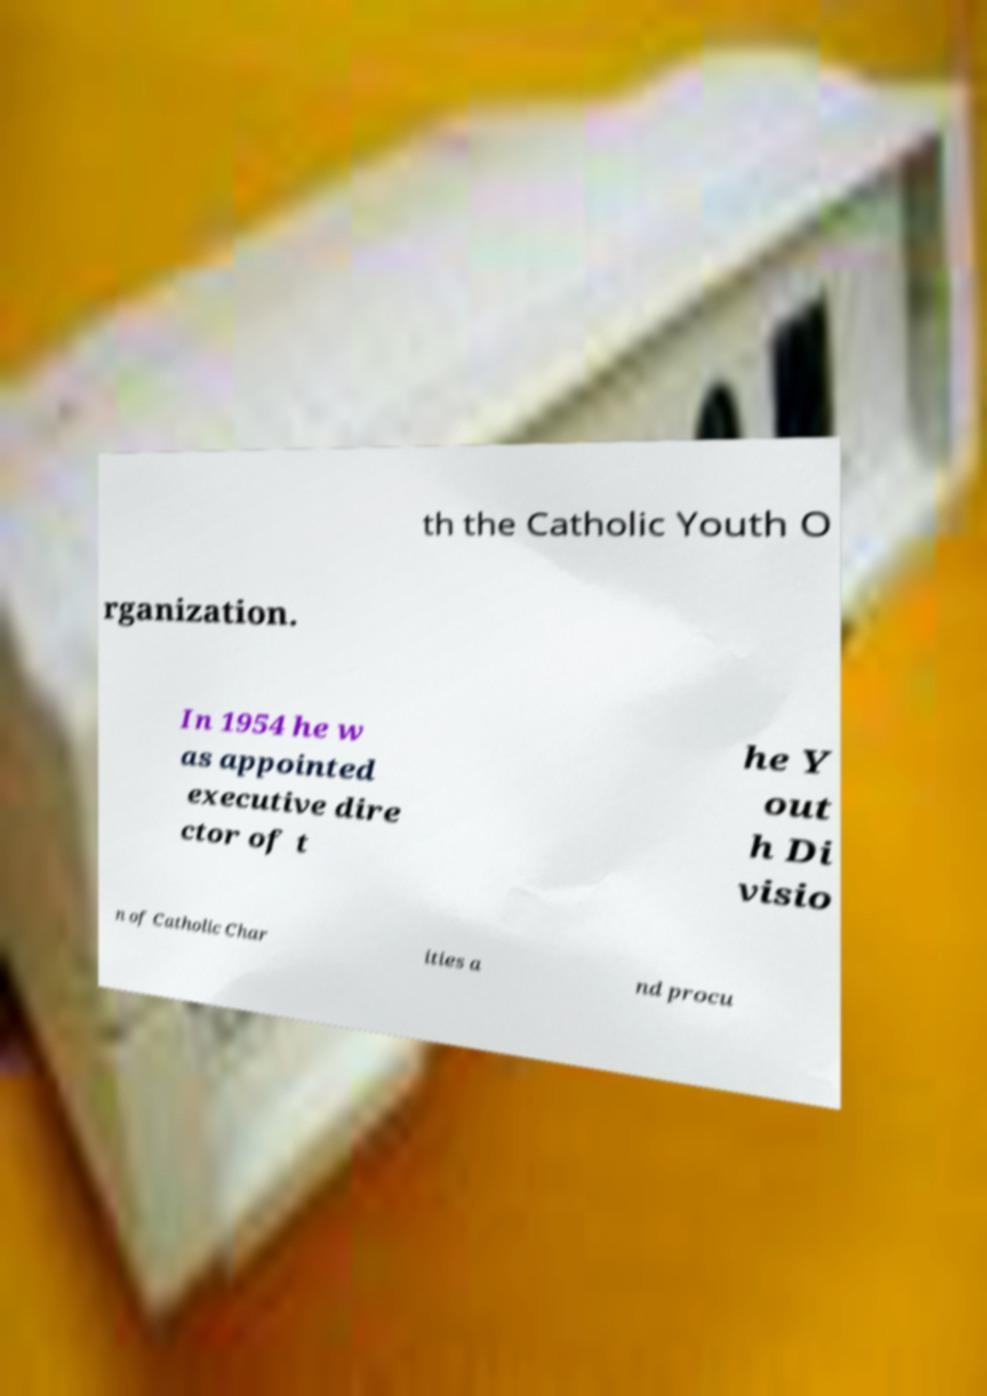Can you read and provide the text displayed in the image?This photo seems to have some interesting text. Can you extract and type it out for me? th the Catholic Youth O rganization. In 1954 he w as appointed executive dire ctor of t he Y out h Di visio n of Catholic Char ities a nd procu 